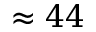<formula> <loc_0><loc_0><loc_500><loc_500>\approx 4 4</formula> 